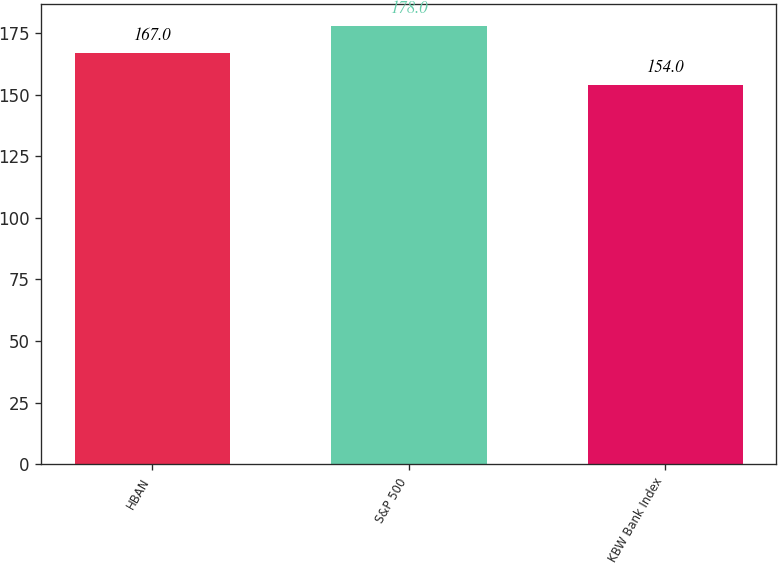<chart> <loc_0><loc_0><loc_500><loc_500><bar_chart><fcel>HBAN<fcel>S&P 500<fcel>KBW Bank Index<nl><fcel>167<fcel>178<fcel>154<nl></chart> 